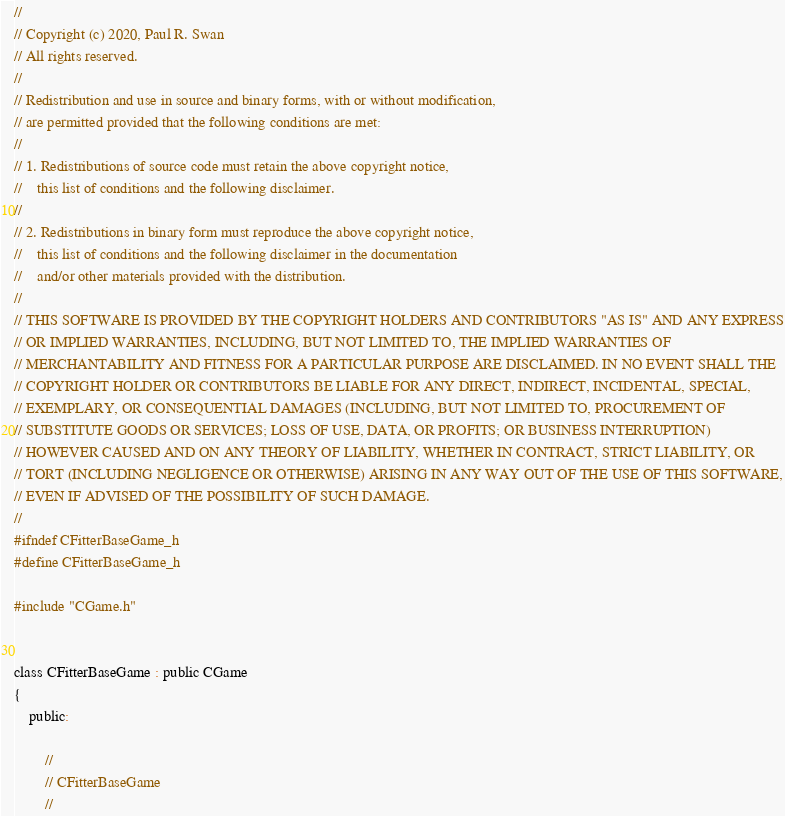Convert code to text. <code><loc_0><loc_0><loc_500><loc_500><_C_>//
// Copyright (c) 2020, Paul R. Swan
// All rights reserved.
//
// Redistribution and use in source and binary forms, with or without modification,
// are permitted provided that the following conditions are met:
//
// 1. Redistributions of source code must retain the above copyright notice,
//    this list of conditions and the following disclaimer.
//
// 2. Redistributions in binary form must reproduce the above copyright notice,
//    this list of conditions and the following disclaimer in the documentation
//    and/or other materials provided with the distribution.
//
// THIS SOFTWARE IS PROVIDED BY THE COPYRIGHT HOLDERS AND CONTRIBUTORS "AS IS" AND ANY EXPRESS
// OR IMPLIED WARRANTIES, INCLUDING, BUT NOT LIMITED TO, THE IMPLIED WARRANTIES OF
// MERCHANTABILITY AND FITNESS FOR A PARTICULAR PURPOSE ARE DISCLAIMED. IN NO EVENT SHALL THE
// COPYRIGHT HOLDER OR CONTRIBUTORS BE LIABLE FOR ANY DIRECT, INDIRECT, INCIDENTAL, SPECIAL,
// EXEMPLARY, OR CONSEQUENTIAL DAMAGES (INCLUDING, BUT NOT LIMITED TO, PROCUREMENT OF
// SUBSTITUTE GOODS OR SERVICES; LOSS OF USE, DATA, OR PROFITS; OR BUSINESS INTERRUPTION)
// HOWEVER CAUSED AND ON ANY THEORY OF LIABILITY, WHETHER IN CONTRACT, STRICT LIABILITY, OR
// TORT (INCLUDING NEGLIGENCE OR OTHERWISE) ARISING IN ANY WAY OUT OF THE USE OF THIS SOFTWARE,
// EVEN IF ADVISED OF THE POSSIBILITY OF SUCH DAMAGE.
//
#ifndef CFitterBaseGame_h
#define CFitterBaseGame_h

#include "CGame.h"


class CFitterBaseGame : public CGame
{
    public:

        //
        // CFitterBaseGame
        //
</code> 